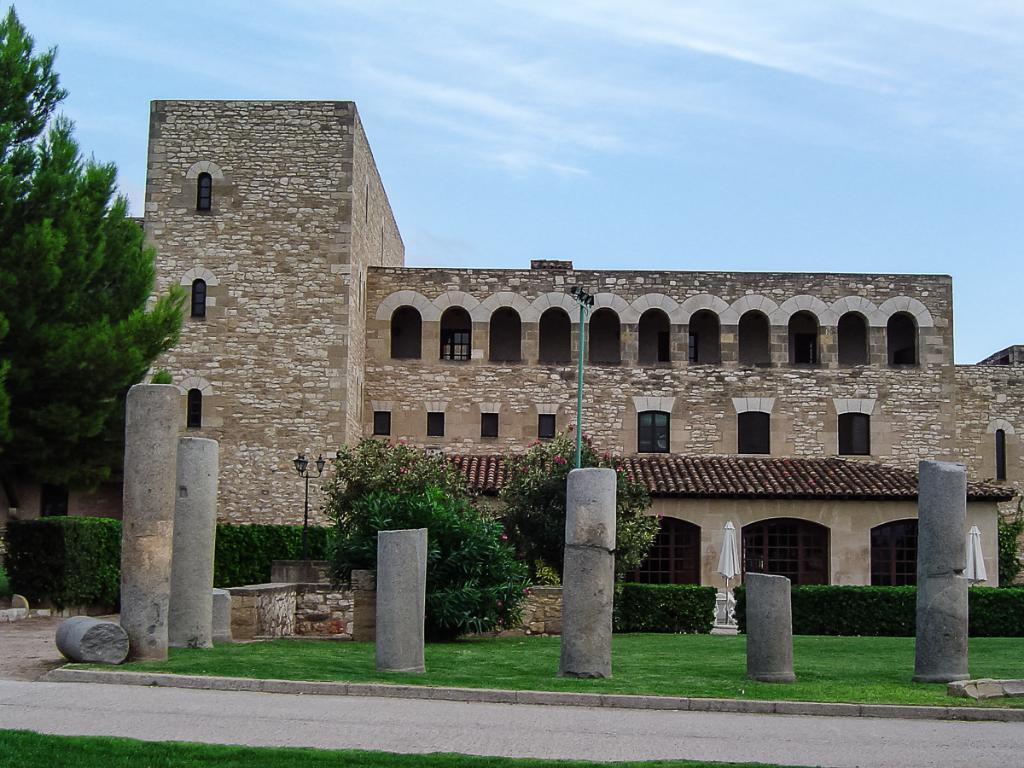What type of structure is present in the image? There is a building in the image. What feature can be seen on the building? The building has windows. What are the light-poles in the image used for? The light-poles in the image are used for illumination. What type of vegetation is present in the image? There are trees in the image. What architectural elements can be seen in the image? The image contains pillars. What is the color of the sky in the image? The sky is blue and white in color. Can you touch the van in the image? There is no van present in the image, so it cannot be touched. 